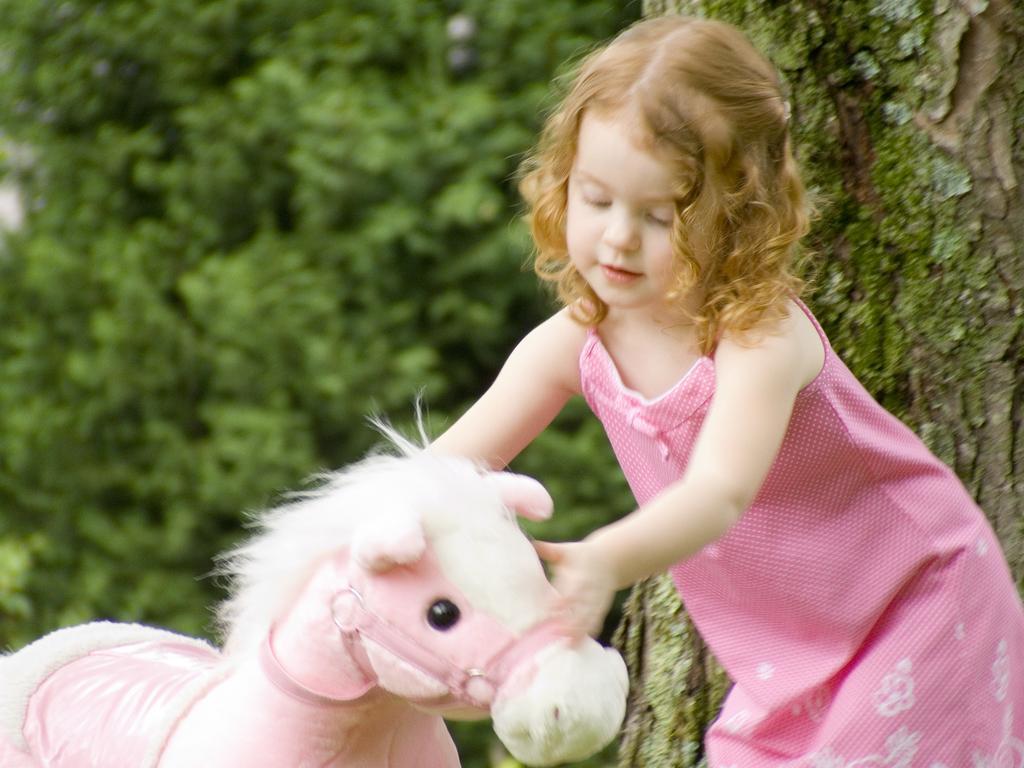In one or two sentences, can you explain what this image depicts? On the right side of the image there is a girl standing, she is wearing a pink dress. On the right there is a toy the girl is playing with that toy. In the background there is a tree. 